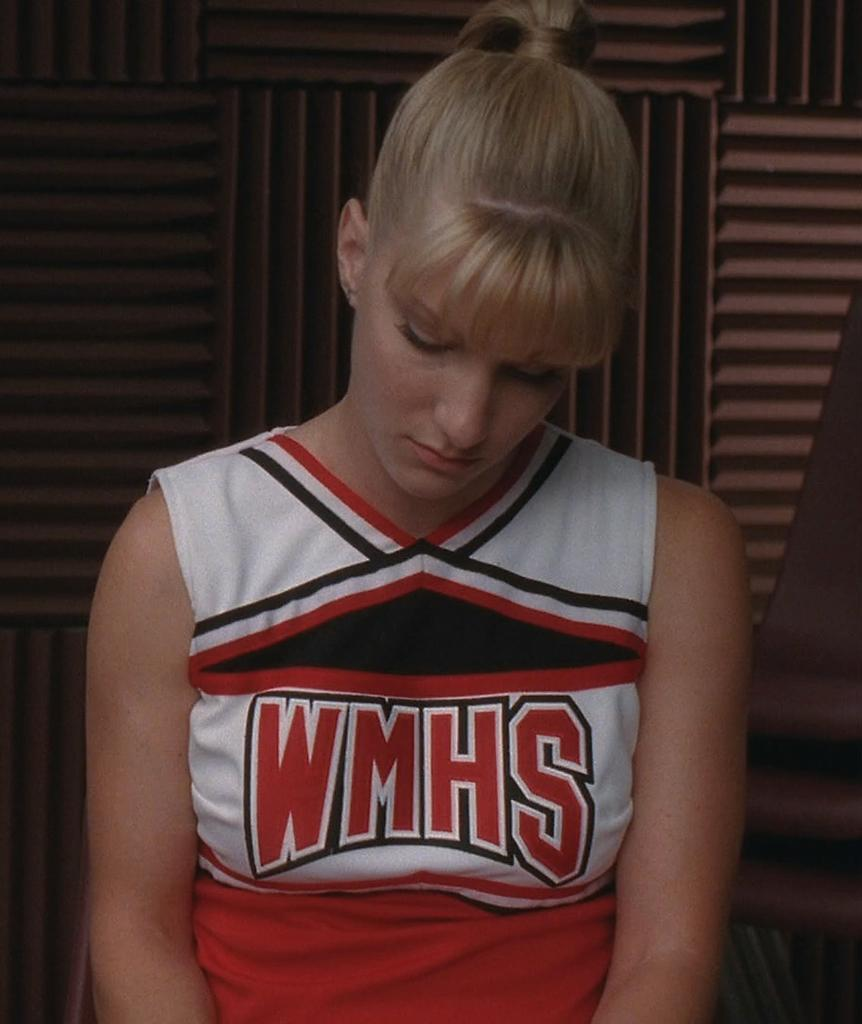<image>
Present a compact description of the photo's key features. A sad looking woman wears a WMHS uniform. 